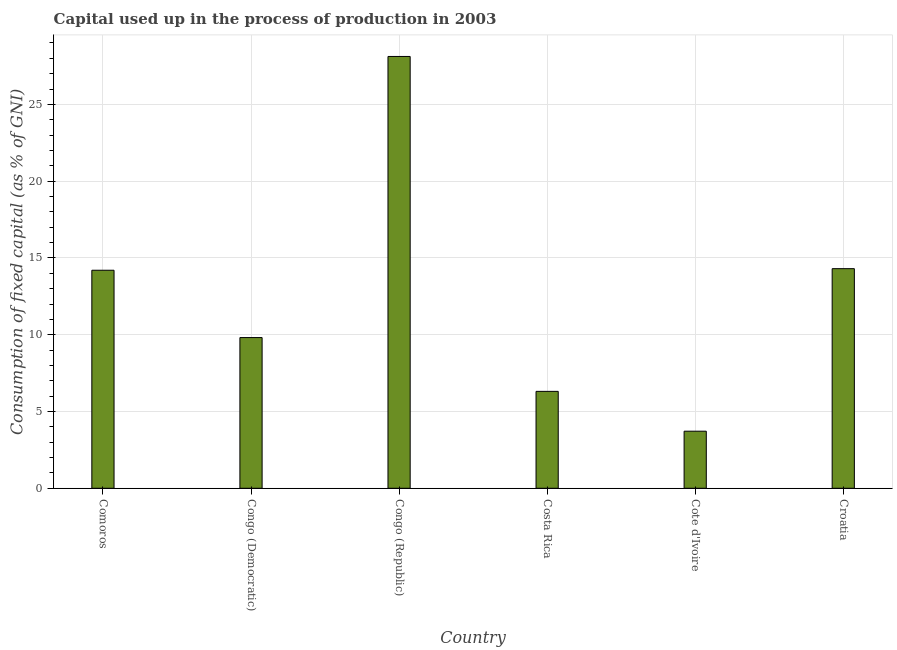What is the title of the graph?
Make the answer very short. Capital used up in the process of production in 2003. What is the label or title of the Y-axis?
Give a very brief answer. Consumption of fixed capital (as % of GNI). What is the consumption of fixed capital in Congo (Democratic)?
Provide a short and direct response. 9.81. Across all countries, what is the maximum consumption of fixed capital?
Offer a very short reply. 28.12. Across all countries, what is the minimum consumption of fixed capital?
Keep it short and to the point. 3.72. In which country was the consumption of fixed capital maximum?
Give a very brief answer. Congo (Republic). In which country was the consumption of fixed capital minimum?
Your answer should be very brief. Cote d'Ivoire. What is the sum of the consumption of fixed capital?
Ensure brevity in your answer.  76.46. What is the difference between the consumption of fixed capital in Congo (Democratic) and Cote d'Ivoire?
Make the answer very short. 6.1. What is the average consumption of fixed capital per country?
Give a very brief answer. 12.74. What is the median consumption of fixed capital?
Give a very brief answer. 12.01. What is the ratio of the consumption of fixed capital in Congo (Republic) to that in Costa Rica?
Provide a succinct answer. 4.46. Is the consumption of fixed capital in Comoros less than that in Croatia?
Provide a succinct answer. Yes. Is the difference between the consumption of fixed capital in Congo (Democratic) and Croatia greater than the difference between any two countries?
Your answer should be very brief. No. What is the difference between the highest and the second highest consumption of fixed capital?
Your answer should be very brief. 13.82. Is the sum of the consumption of fixed capital in Comoros and Costa Rica greater than the maximum consumption of fixed capital across all countries?
Provide a succinct answer. No. What is the difference between the highest and the lowest consumption of fixed capital?
Provide a short and direct response. 24.4. How many countries are there in the graph?
Make the answer very short. 6. What is the difference between two consecutive major ticks on the Y-axis?
Provide a short and direct response. 5. Are the values on the major ticks of Y-axis written in scientific E-notation?
Provide a short and direct response. No. What is the Consumption of fixed capital (as % of GNI) of Comoros?
Provide a short and direct response. 14.2. What is the Consumption of fixed capital (as % of GNI) in Congo (Democratic)?
Your answer should be compact. 9.81. What is the Consumption of fixed capital (as % of GNI) in Congo (Republic)?
Your response must be concise. 28.12. What is the Consumption of fixed capital (as % of GNI) in Costa Rica?
Give a very brief answer. 6.31. What is the Consumption of fixed capital (as % of GNI) in Cote d'Ivoire?
Provide a succinct answer. 3.72. What is the Consumption of fixed capital (as % of GNI) of Croatia?
Ensure brevity in your answer.  14.3. What is the difference between the Consumption of fixed capital (as % of GNI) in Comoros and Congo (Democratic)?
Provide a succinct answer. 4.38. What is the difference between the Consumption of fixed capital (as % of GNI) in Comoros and Congo (Republic)?
Offer a terse response. -13.92. What is the difference between the Consumption of fixed capital (as % of GNI) in Comoros and Costa Rica?
Make the answer very short. 7.89. What is the difference between the Consumption of fixed capital (as % of GNI) in Comoros and Cote d'Ivoire?
Your response must be concise. 10.48. What is the difference between the Consumption of fixed capital (as % of GNI) in Comoros and Croatia?
Your response must be concise. -0.1. What is the difference between the Consumption of fixed capital (as % of GNI) in Congo (Democratic) and Congo (Republic)?
Make the answer very short. -18.31. What is the difference between the Consumption of fixed capital (as % of GNI) in Congo (Democratic) and Costa Rica?
Offer a very short reply. 3.5. What is the difference between the Consumption of fixed capital (as % of GNI) in Congo (Democratic) and Cote d'Ivoire?
Ensure brevity in your answer.  6.1. What is the difference between the Consumption of fixed capital (as % of GNI) in Congo (Democratic) and Croatia?
Ensure brevity in your answer.  -4.49. What is the difference between the Consumption of fixed capital (as % of GNI) in Congo (Republic) and Costa Rica?
Ensure brevity in your answer.  21.81. What is the difference between the Consumption of fixed capital (as % of GNI) in Congo (Republic) and Cote d'Ivoire?
Offer a terse response. 24.4. What is the difference between the Consumption of fixed capital (as % of GNI) in Congo (Republic) and Croatia?
Offer a terse response. 13.82. What is the difference between the Consumption of fixed capital (as % of GNI) in Costa Rica and Cote d'Ivoire?
Make the answer very short. 2.59. What is the difference between the Consumption of fixed capital (as % of GNI) in Costa Rica and Croatia?
Provide a short and direct response. -7.99. What is the difference between the Consumption of fixed capital (as % of GNI) in Cote d'Ivoire and Croatia?
Offer a terse response. -10.58. What is the ratio of the Consumption of fixed capital (as % of GNI) in Comoros to that in Congo (Democratic)?
Your response must be concise. 1.45. What is the ratio of the Consumption of fixed capital (as % of GNI) in Comoros to that in Congo (Republic)?
Give a very brief answer. 0.51. What is the ratio of the Consumption of fixed capital (as % of GNI) in Comoros to that in Costa Rica?
Make the answer very short. 2.25. What is the ratio of the Consumption of fixed capital (as % of GNI) in Comoros to that in Cote d'Ivoire?
Your answer should be compact. 3.82. What is the ratio of the Consumption of fixed capital (as % of GNI) in Congo (Democratic) to that in Congo (Republic)?
Provide a succinct answer. 0.35. What is the ratio of the Consumption of fixed capital (as % of GNI) in Congo (Democratic) to that in Costa Rica?
Your answer should be very brief. 1.55. What is the ratio of the Consumption of fixed capital (as % of GNI) in Congo (Democratic) to that in Cote d'Ivoire?
Provide a succinct answer. 2.64. What is the ratio of the Consumption of fixed capital (as % of GNI) in Congo (Democratic) to that in Croatia?
Make the answer very short. 0.69. What is the ratio of the Consumption of fixed capital (as % of GNI) in Congo (Republic) to that in Costa Rica?
Ensure brevity in your answer.  4.46. What is the ratio of the Consumption of fixed capital (as % of GNI) in Congo (Republic) to that in Cote d'Ivoire?
Make the answer very short. 7.57. What is the ratio of the Consumption of fixed capital (as % of GNI) in Congo (Republic) to that in Croatia?
Your answer should be compact. 1.97. What is the ratio of the Consumption of fixed capital (as % of GNI) in Costa Rica to that in Cote d'Ivoire?
Your answer should be compact. 1.7. What is the ratio of the Consumption of fixed capital (as % of GNI) in Costa Rica to that in Croatia?
Keep it short and to the point. 0.44. What is the ratio of the Consumption of fixed capital (as % of GNI) in Cote d'Ivoire to that in Croatia?
Provide a short and direct response. 0.26. 